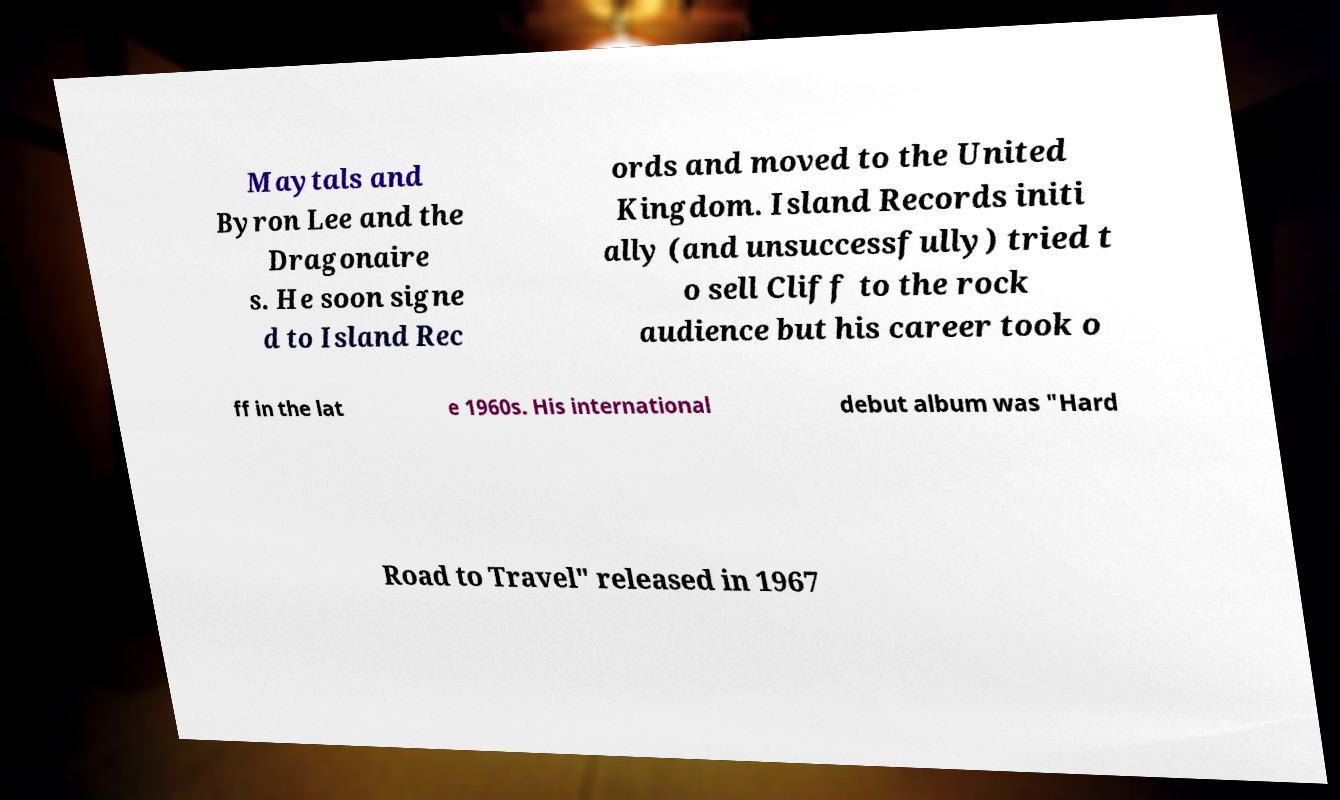Please read and relay the text visible in this image. What does it say? Maytals and Byron Lee and the Dragonaire s. He soon signe d to Island Rec ords and moved to the United Kingdom. Island Records initi ally (and unsuccessfully) tried t o sell Cliff to the rock audience but his career took o ff in the lat e 1960s. His international debut album was "Hard Road to Travel" released in 1967 